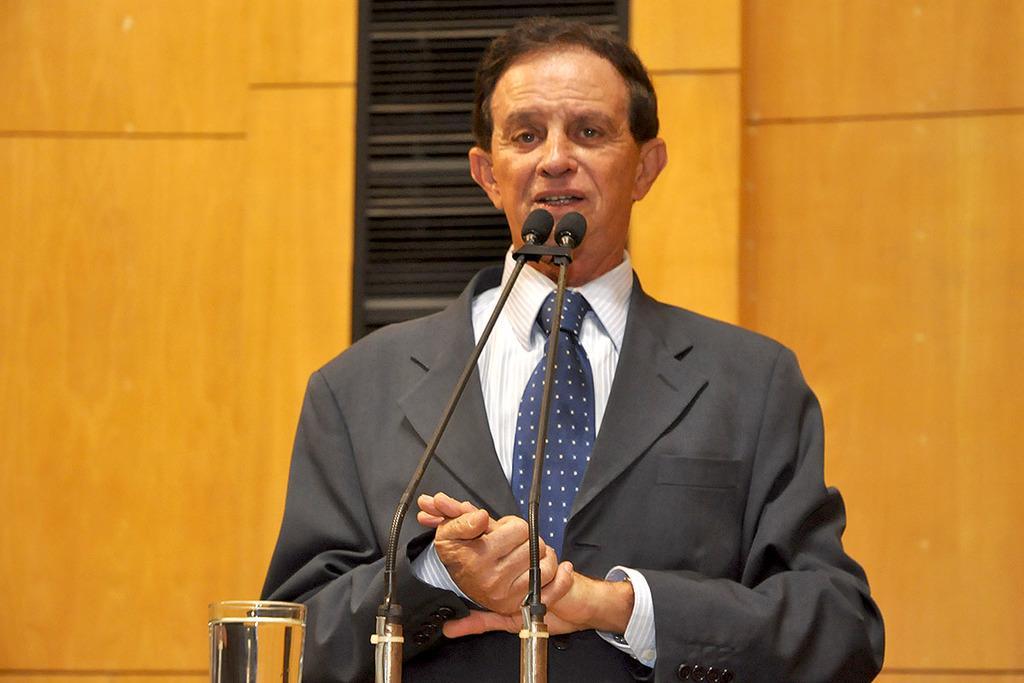In one or two sentences, can you explain what this image depicts? In this image, we can see a man in a suit is talking in-front of microphones. At the bottom, we can see a glass with water. Background there is a wall. 